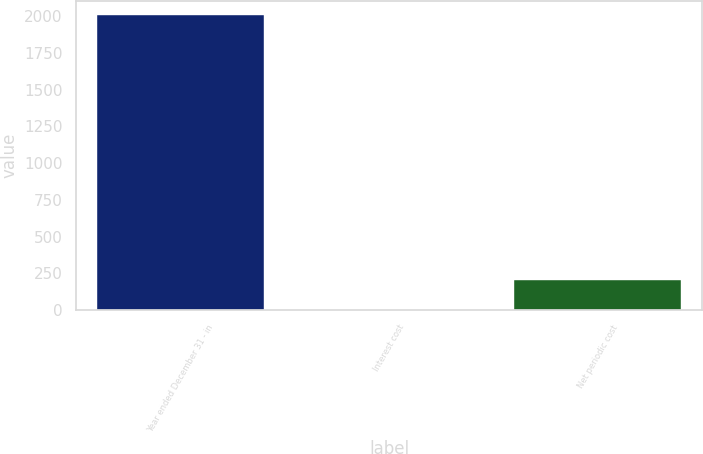<chart> <loc_0><loc_0><loc_500><loc_500><bar_chart><fcel>Year ended December 31 - in<fcel>Interest cost<fcel>Net periodic cost<nl><fcel>2005<fcel>4<fcel>204.1<nl></chart> 